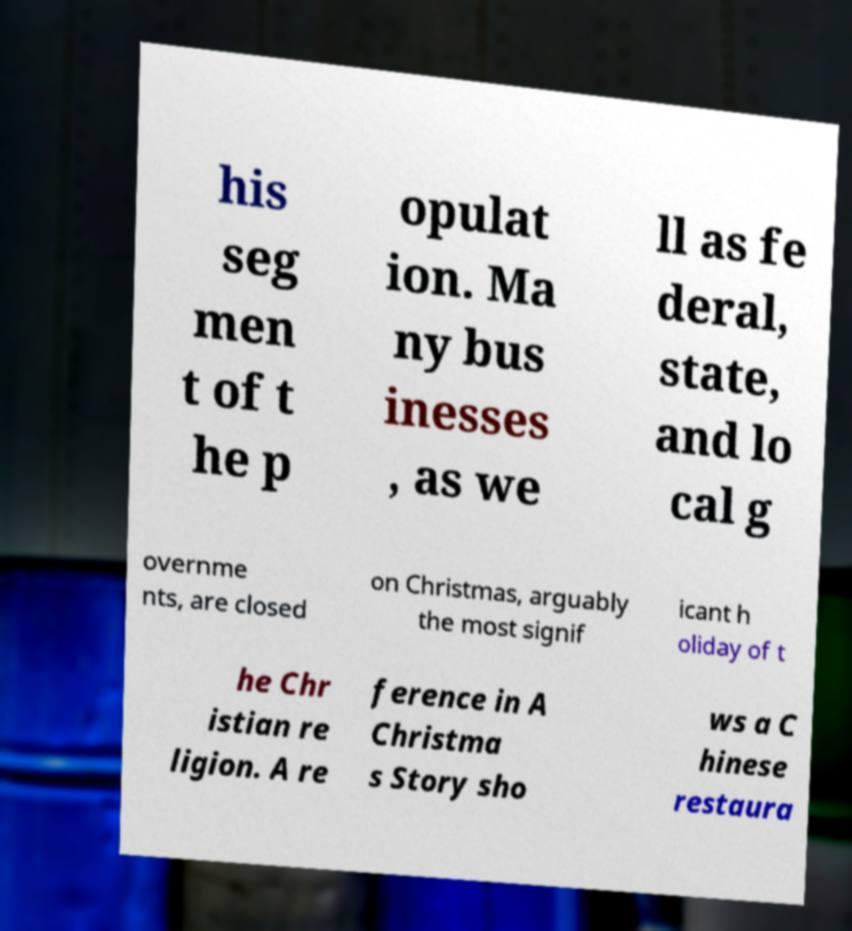Please read and relay the text visible in this image. What does it say? his seg men t of t he p opulat ion. Ma ny bus inesses , as we ll as fe deral, state, and lo cal g overnme nts, are closed on Christmas, arguably the most signif icant h oliday of t he Chr istian re ligion. A re ference in A Christma s Story sho ws a C hinese restaura 